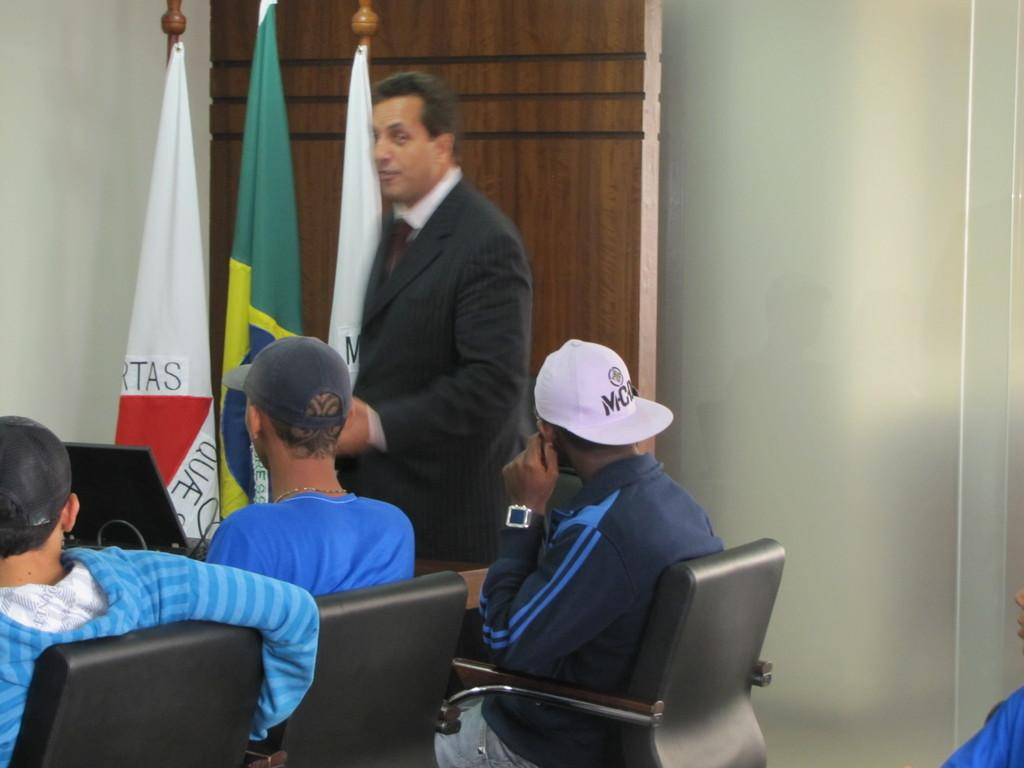How many people are sitting in the image? There are three persons sitting on chairs in the image. What is the position of the person standing in the image? There is a person standing in front of the seated persons. What can be seen in the background of the image? There is a wall and three flags in the background of the image. What type of lamp is being used to illuminate the ice in the image? There is no ice or lamp present in the image. 